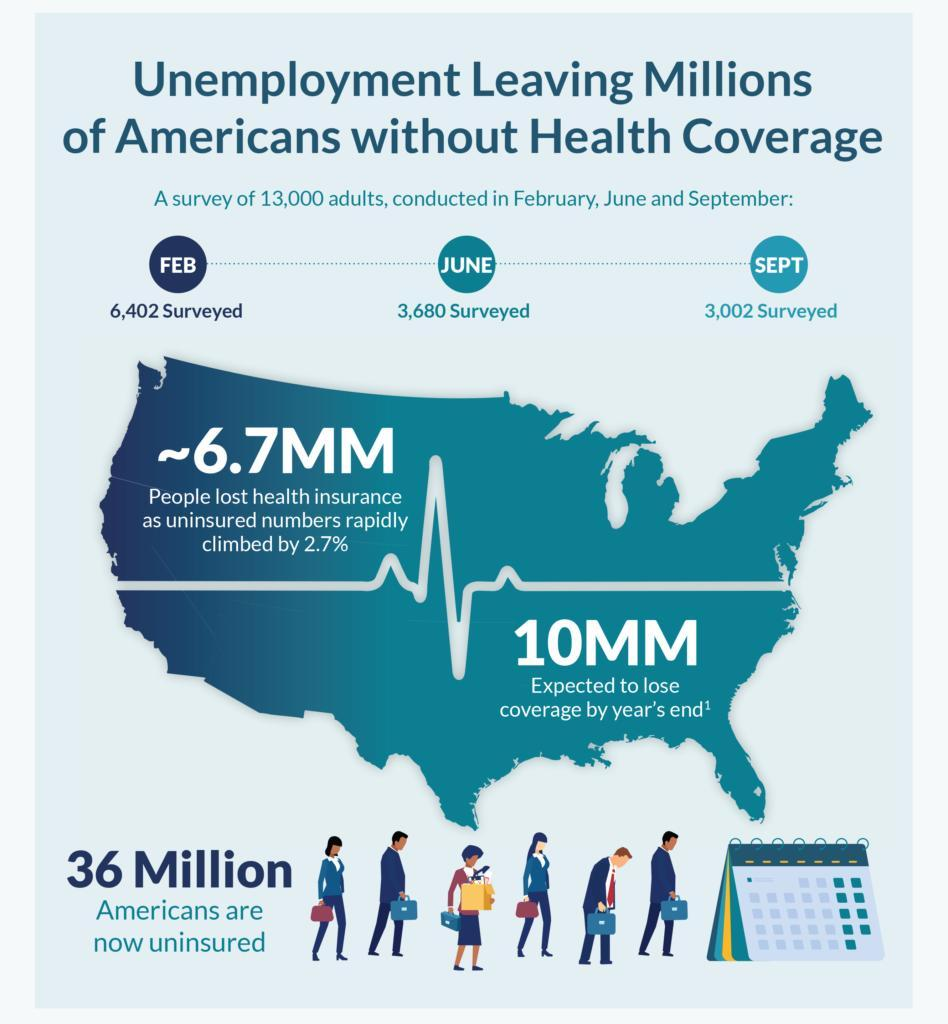How many more people were surveyed in June when compared to September
Answer the question with a short phrase. 678 how many people were surveyed in February 6,402 What is the colour of the tie of the person who is stooping, red or blue red What is the total count of Saturday and Sunday in the calender 9 